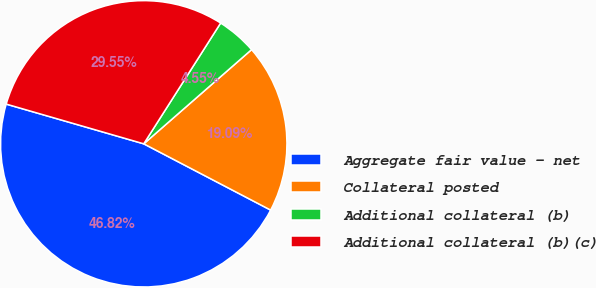Convert chart. <chart><loc_0><loc_0><loc_500><loc_500><pie_chart><fcel>Aggregate fair value - net<fcel>Collateral posted<fcel>Additional collateral (b)<fcel>Additional collateral (b)(c)<nl><fcel>46.82%<fcel>19.09%<fcel>4.55%<fcel>29.55%<nl></chart> 